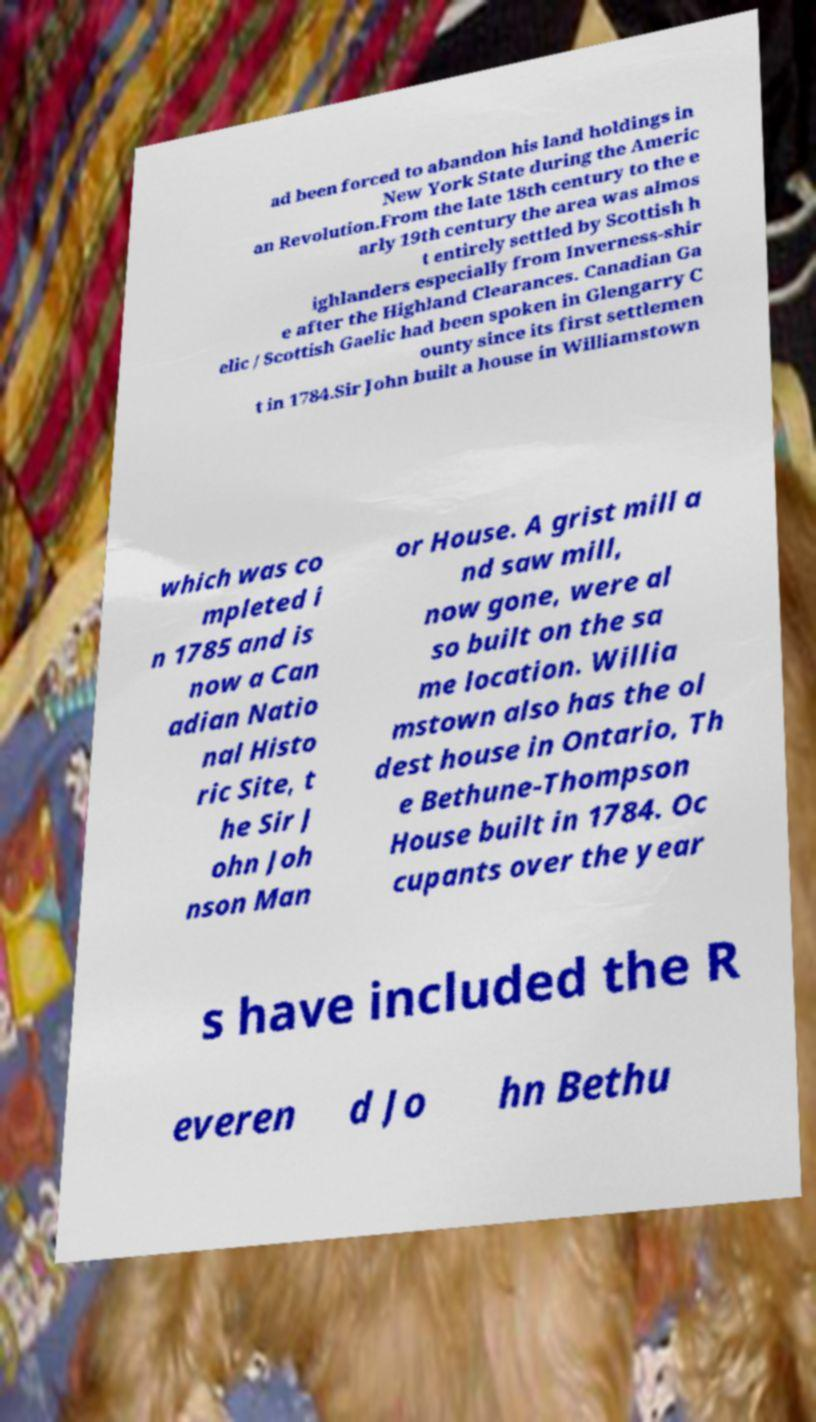There's text embedded in this image that I need extracted. Can you transcribe it verbatim? ad been forced to abandon his land holdings in New York State during the Americ an Revolution.From the late 18th century to the e arly 19th century the area was almos t entirely settled by Scottish h ighlanders especially from Inverness-shir e after the Highland Clearances. Canadian Ga elic / Scottish Gaelic had been spoken in Glengarry C ounty since its first settlemen t in 1784.Sir John built a house in Williamstown which was co mpleted i n 1785 and is now a Can adian Natio nal Histo ric Site, t he Sir J ohn Joh nson Man or House. A grist mill a nd saw mill, now gone, were al so built on the sa me location. Willia mstown also has the ol dest house in Ontario, Th e Bethune-Thompson House built in 1784. Oc cupants over the year s have included the R everen d Jo hn Bethu 